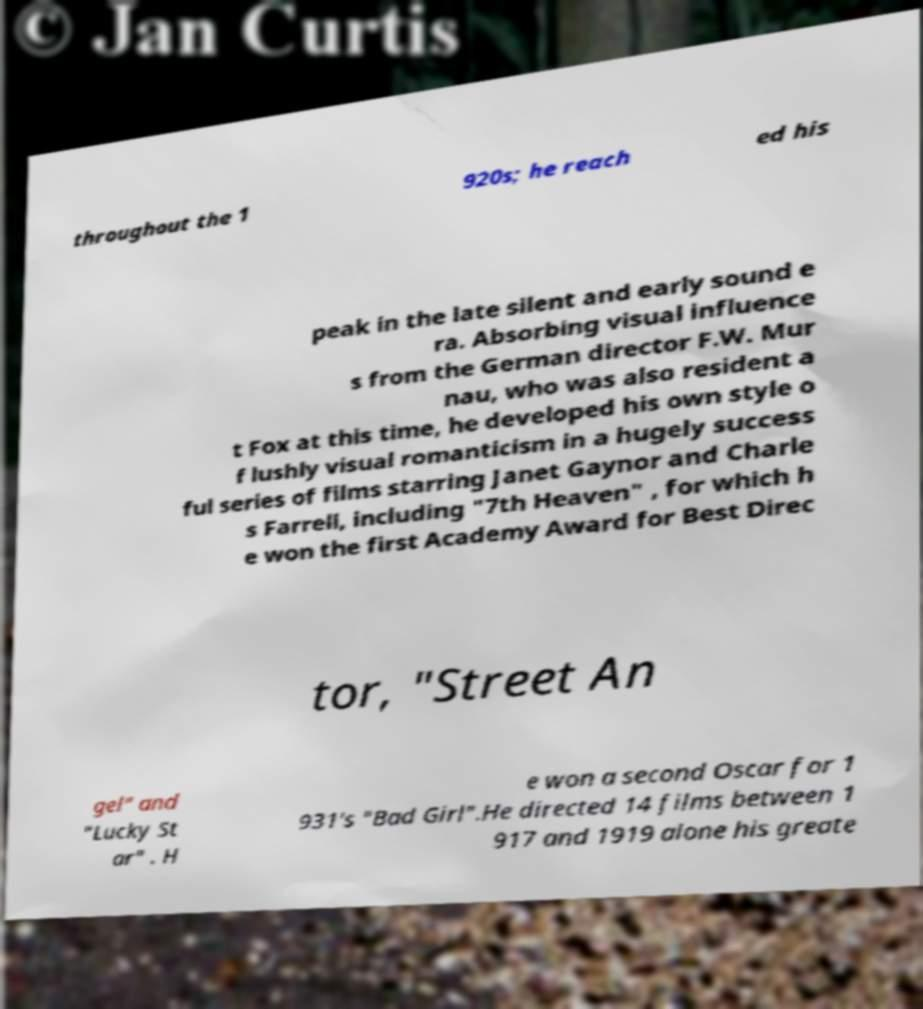Can you accurately transcribe the text from the provided image for me? throughout the 1 920s; he reach ed his peak in the late silent and early sound e ra. Absorbing visual influence s from the German director F.W. Mur nau, who was also resident a t Fox at this time, he developed his own style o f lushly visual romanticism in a hugely success ful series of films starring Janet Gaynor and Charle s Farrell, including "7th Heaven" , for which h e won the first Academy Award for Best Direc tor, "Street An gel" and "Lucky St ar" . H e won a second Oscar for 1 931's "Bad Girl".He directed 14 films between 1 917 and 1919 alone his greate 